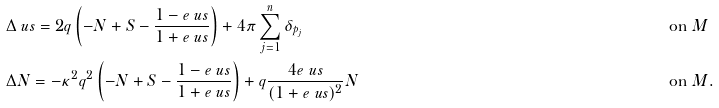<formula> <loc_0><loc_0><loc_500><loc_500>& \Delta \ u s = 2 q \left ( - N + S - \frac { 1 - e ^ { \ } u s } { 1 + e ^ { \ } u s } \right ) + 4 \pi \sum _ { j = 1 } ^ { n } \delta _ { p _ { j } } & & \text {on} \ M \\ & \Delta N = - \kappa ^ { 2 } q ^ { 2 } \left ( - N + S - \frac { 1 - e ^ { \ } u s } { 1 + e ^ { \ } u s } \right ) + q \frac { 4 e ^ { \ } u s } { ( 1 + e ^ { \ } u s ) ^ { 2 } } N & & \text {on} \ M .</formula> 